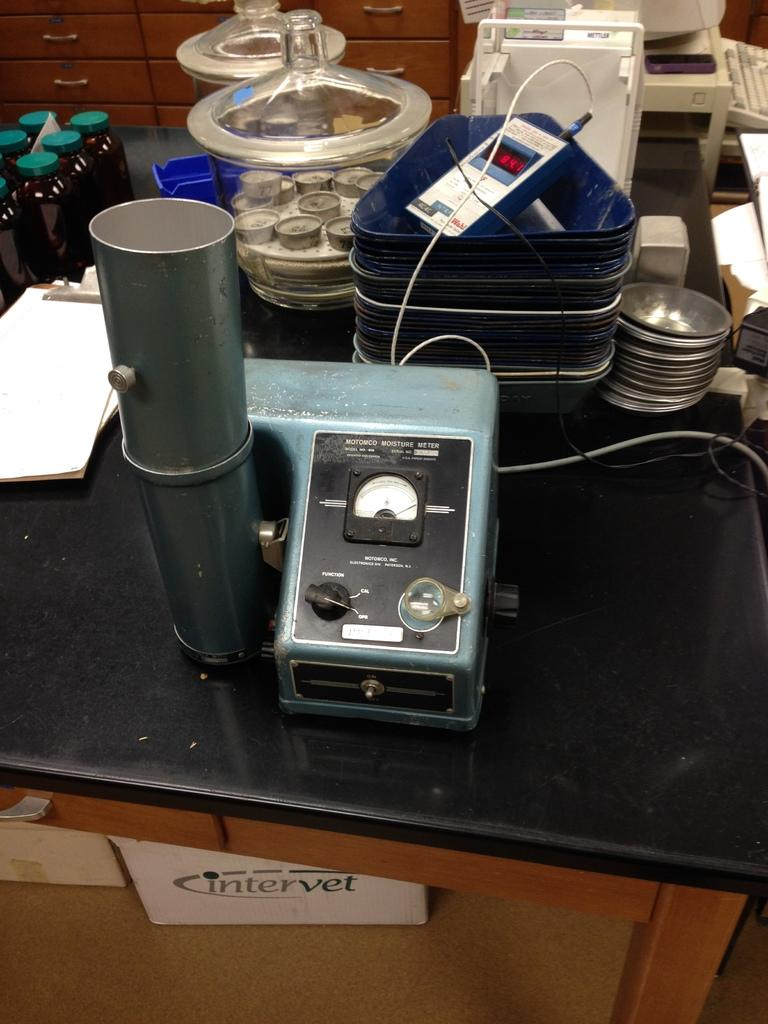<image>
Provide a brief description of the given image. A black lab bench cluttered with scientific instruments, including a moisture meter. 